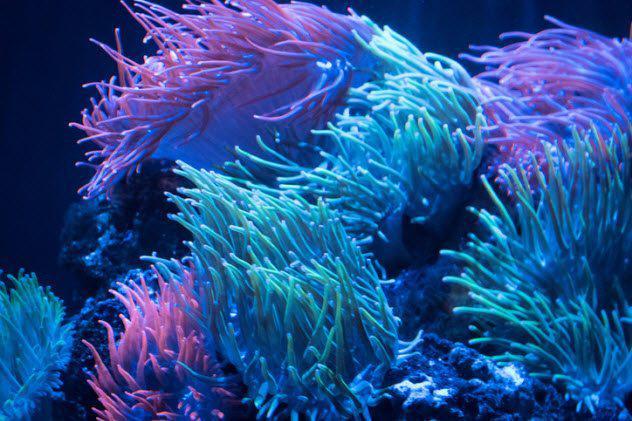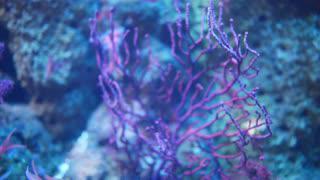The first image is the image on the left, the second image is the image on the right. For the images shown, is this caption "There are clown fish near the sea anemone." true? Answer yes or no. No. The first image is the image on the left, the second image is the image on the right. Given the left and right images, does the statement "There are at least two fishes in the pair of images." hold true? Answer yes or no. No. 